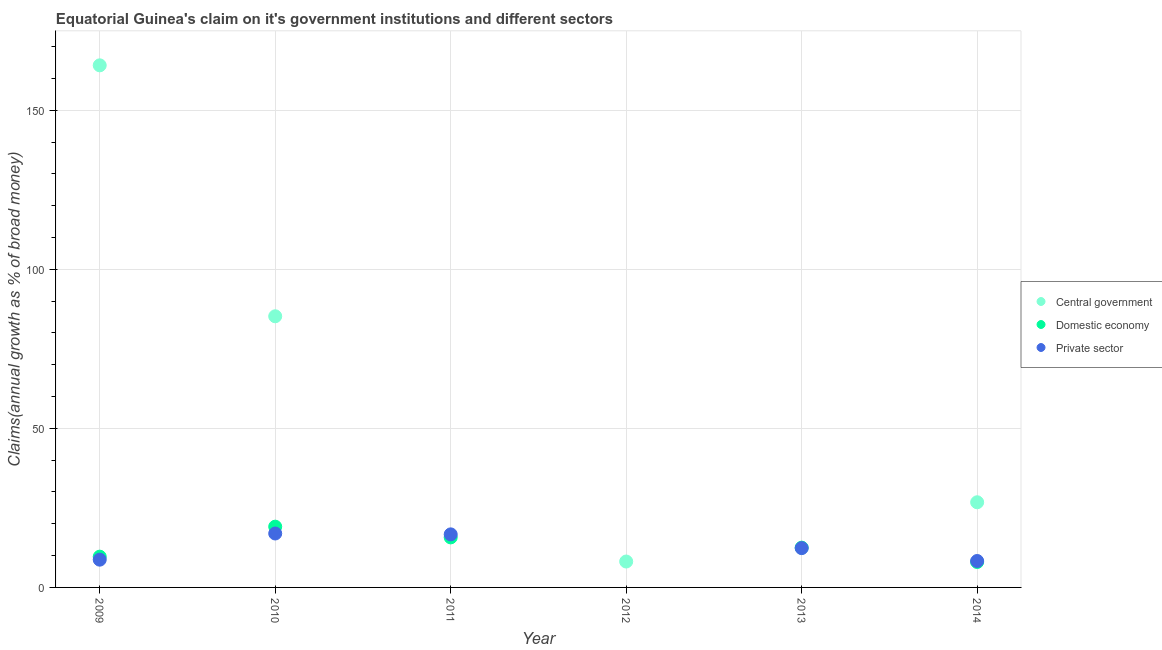How many different coloured dotlines are there?
Provide a short and direct response. 3. What is the percentage of claim on the private sector in 2013?
Offer a terse response. 12.36. Across all years, what is the maximum percentage of claim on the domestic economy?
Your answer should be very brief. 19.1. What is the total percentage of claim on the private sector in the graph?
Provide a short and direct response. 63.03. What is the difference between the percentage of claim on the central government in 2009 and that in 2014?
Offer a very short reply. 137.36. What is the difference between the percentage of claim on the central government in 2011 and the percentage of claim on the domestic economy in 2014?
Provide a succinct answer. -7.99. What is the average percentage of claim on the domestic economy per year?
Your answer should be compact. 10.83. In the year 2014, what is the difference between the percentage of claim on the central government and percentage of claim on the domestic economy?
Your answer should be compact. 18.78. What is the ratio of the percentage of claim on the private sector in 2010 to that in 2013?
Offer a terse response. 1.37. What is the difference between the highest and the second highest percentage of claim on the domestic economy?
Offer a very short reply. 3.37. What is the difference between the highest and the lowest percentage of claim on the central government?
Provide a succinct answer. 164.13. In how many years, is the percentage of claim on the domestic economy greater than the average percentage of claim on the domestic economy taken over all years?
Your response must be concise. 3. Is it the case that in every year, the sum of the percentage of claim on the central government and percentage of claim on the domestic economy is greater than the percentage of claim on the private sector?
Your answer should be compact. No. Is the percentage of claim on the central government strictly greater than the percentage of claim on the private sector over the years?
Provide a succinct answer. No. Is the percentage of claim on the domestic economy strictly less than the percentage of claim on the private sector over the years?
Provide a succinct answer. No. How many years are there in the graph?
Keep it short and to the point. 6. Are the values on the major ticks of Y-axis written in scientific E-notation?
Your answer should be very brief. No. Does the graph contain any zero values?
Give a very brief answer. Yes. Does the graph contain grids?
Offer a very short reply. Yes. Where does the legend appear in the graph?
Give a very brief answer. Center right. What is the title of the graph?
Offer a terse response. Equatorial Guinea's claim on it's government institutions and different sectors. What is the label or title of the X-axis?
Offer a very short reply. Year. What is the label or title of the Y-axis?
Give a very brief answer. Claims(annual growth as % of broad money). What is the Claims(annual growth as % of broad money) of Central government in 2009?
Give a very brief answer. 164.13. What is the Claims(annual growth as % of broad money) of Domestic economy in 2009?
Provide a succinct answer. 9.67. What is the Claims(annual growth as % of broad money) of Private sector in 2009?
Offer a terse response. 8.73. What is the Claims(annual growth as % of broad money) of Central government in 2010?
Your answer should be very brief. 85.24. What is the Claims(annual growth as % of broad money) in Domestic economy in 2010?
Give a very brief answer. 19.1. What is the Claims(annual growth as % of broad money) of Private sector in 2010?
Keep it short and to the point. 16.95. What is the Claims(annual growth as % of broad money) in Central government in 2011?
Your answer should be very brief. 0. What is the Claims(annual growth as % of broad money) in Domestic economy in 2011?
Your answer should be very brief. 15.73. What is the Claims(annual growth as % of broad money) in Private sector in 2011?
Offer a terse response. 16.68. What is the Claims(annual growth as % of broad money) of Central government in 2012?
Offer a very short reply. 8.14. What is the Claims(annual growth as % of broad money) of Private sector in 2012?
Provide a short and direct response. 0. What is the Claims(annual growth as % of broad money) in Domestic economy in 2013?
Ensure brevity in your answer.  12.51. What is the Claims(annual growth as % of broad money) in Private sector in 2013?
Ensure brevity in your answer.  12.36. What is the Claims(annual growth as % of broad money) of Central government in 2014?
Keep it short and to the point. 26.77. What is the Claims(annual growth as % of broad money) of Domestic economy in 2014?
Your answer should be very brief. 7.99. What is the Claims(annual growth as % of broad money) in Private sector in 2014?
Ensure brevity in your answer.  8.31. Across all years, what is the maximum Claims(annual growth as % of broad money) of Central government?
Offer a terse response. 164.13. Across all years, what is the maximum Claims(annual growth as % of broad money) of Domestic economy?
Provide a succinct answer. 19.1. Across all years, what is the maximum Claims(annual growth as % of broad money) in Private sector?
Provide a succinct answer. 16.95. Across all years, what is the minimum Claims(annual growth as % of broad money) in Domestic economy?
Offer a terse response. 0. What is the total Claims(annual growth as % of broad money) of Central government in the graph?
Your answer should be compact. 284.28. What is the total Claims(annual growth as % of broad money) in Domestic economy in the graph?
Your answer should be compact. 65. What is the total Claims(annual growth as % of broad money) in Private sector in the graph?
Offer a terse response. 63.03. What is the difference between the Claims(annual growth as % of broad money) in Central government in 2009 and that in 2010?
Provide a short and direct response. 78.89. What is the difference between the Claims(annual growth as % of broad money) in Domestic economy in 2009 and that in 2010?
Give a very brief answer. -9.43. What is the difference between the Claims(annual growth as % of broad money) of Private sector in 2009 and that in 2010?
Offer a terse response. -8.23. What is the difference between the Claims(annual growth as % of broad money) of Domestic economy in 2009 and that in 2011?
Ensure brevity in your answer.  -6.05. What is the difference between the Claims(annual growth as % of broad money) in Private sector in 2009 and that in 2011?
Offer a very short reply. -7.96. What is the difference between the Claims(annual growth as % of broad money) of Central government in 2009 and that in 2012?
Your response must be concise. 155.98. What is the difference between the Claims(annual growth as % of broad money) in Domestic economy in 2009 and that in 2013?
Make the answer very short. -2.83. What is the difference between the Claims(annual growth as % of broad money) in Private sector in 2009 and that in 2013?
Your answer should be very brief. -3.63. What is the difference between the Claims(annual growth as % of broad money) of Central government in 2009 and that in 2014?
Your answer should be very brief. 137.36. What is the difference between the Claims(annual growth as % of broad money) of Domestic economy in 2009 and that in 2014?
Ensure brevity in your answer.  1.68. What is the difference between the Claims(annual growth as % of broad money) in Private sector in 2009 and that in 2014?
Your answer should be very brief. 0.42. What is the difference between the Claims(annual growth as % of broad money) in Domestic economy in 2010 and that in 2011?
Give a very brief answer. 3.37. What is the difference between the Claims(annual growth as % of broad money) of Private sector in 2010 and that in 2011?
Your answer should be compact. 0.27. What is the difference between the Claims(annual growth as % of broad money) of Central government in 2010 and that in 2012?
Your answer should be compact. 77.1. What is the difference between the Claims(annual growth as % of broad money) in Domestic economy in 2010 and that in 2013?
Your answer should be compact. 6.6. What is the difference between the Claims(annual growth as % of broad money) in Private sector in 2010 and that in 2013?
Keep it short and to the point. 4.59. What is the difference between the Claims(annual growth as % of broad money) in Central government in 2010 and that in 2014?
Give a very brief answer. 58.47. What is the difference between the Claims(annual growth as % of broad money) of Domestic economy in 2010 and that in 2014?
Offer a very short reply. 11.11. What is the difference between the Claims(annual growth as % of broad money) of Private sector in 2010 and that in 2014?
Ensure brevity in your answer.  8.64. What is the difference between the Claims(annual growth as % of broad money) of Domestic economy in 2011 and that in 2013?
Offer a terse response. 3.22. What is the difference between the Claims(annual growth as % of broad money) in Private sector in 2011 and that in 2013?
Ensure brevity in your answer.  4.32. What is the difference between the Claims(annual growth as % of broad money) of Domestic economy in 2011 and that in 2014?
Provide a succinct answer. 7.73. What is the difference between the Claims(annual growth as % of broad money) in Private sector in 2011 and that in 2014?
Your answer should be very brief. 8.37. What is the difference between the Claims(annual growth as % of broad money) of Central government in 2012 and that in 2014?
Give a very brief answer. -18.63. What is the difference between the Claims(annual growth as % of broad money) in Domestic economy in 2013 and that in 2014?
Provide a succinct answer. 4.51. What is the difference between the Claims(annual growth as % of broad money) of Private sector in 2013 and that in 2014?
Offer a terse response. 4.05. What is the difference between the Claims(annual growth as % of broad money) in Central government in 2009 and the Claims(annual growth as % of broad money) in Domestic economy in 2010?
Your answer should be very brief. 145.03. What is the difference between the Claims(annual growth as % of broad money) of Central government in 2009 and the Claims(annual growth as % of broad money) of Private sector in 2010?
Make the answer very short. 147.17. What is the difference between the Claims(annual growth as % of broad money) in Domestic economy in 2009 and the Claims(annual growth as % of broad money) in Private sector in 2010?
Provide a short and direct response. -7.28. What is the difference between the Claims(annual growth as % of broad money) of Central government in 2009 and the Claims(annual growth as % of broad money) of Domestic economy in 2011?
Your response must be concise. 148.4. What is the difference between the Claims(annual growth as % of broad money) in Central government in 2009 and the Claims(annual growth as % of broad money) in Private sector in 2011?
Your answer should be very brief. 147.45. What is the difference between the Claims(annual growth as % of broad money) in Domestic economy in 2009 and the Claims(annual growth as % of broad money) in Private sector in 2011?
Your response must be concise. -7.01. What is the difference between the Claims(annual growth as % of broad money) of Central government in 2009 and the Claims(annual growth as % of broad money) of Domestic economy in 2013?
Provide a succinct answer. 151.62. What is the difference between the Claims(annual growth as % of broad money) of Central government in 2009 and the Claims(annual growth as % of broad money) of Private sector in 2013?
Keep it short and to the point. 151.77. What is the difference between the Claims(annual growth as % of broad money) of Domestic economy in 2009 and the Claims(annual growth as % of broad money) of Private sector in 2013?
Provide a short and direct response. -2.69. What is the difference between the Claims(annual growth as % of broad money) of Central government in 2009 and the Claims(annual growth as % of broad money) of Domestic economy in 2014?
Give a very brief answer. 156.13. What is the difference between the Claims(annual growth as % of broad money) of Central government in 2009 and the Claims(annual growth as % of broad money) of Private sector in 2014?
Your response must be concise. 155.82. What is the difference between the Claims(annual growth as % of broad money) in Domestic economy in 2009 and the Claims(annual growth as % of broad money) in Private sector in 2014?
Your answer should be compact. 1.36. What is the difference between the Claims(annual growth as % of broad money) of Central government in 2010 and the Claims(annual growth as % of broad money) of Domestic economy in 2011?
Your answer should be very brief. 69.51. What is the difference between the Claims(annual growth as % of broad money) of Central government in 2010 and the Claims(annual growth as % of broad money) of Private sector in 2011?
Your answer should be compact. 68.56. What is the difference between the Claims(annual growth as % of broad money) of Domestic economy in 2010 and the Claims(annual growth as % of broad money) of Private sector in 2011?
Your response must be concise. 2.42. What is the difference between the Claims(annual growth as % of broad money) of Central government in 2010 and the Claims(annual growth as % of broad money) of Domestic economy in 2013?
Offer a very short reply. 72.73. What is the difference between the Claims(annual growth as % of broad money) in Central government in 2010 and the Claims(annual growth as % of broad money) in Private sector in 2013?
Make the answer very short. 72.88. What is the difference between the Claims(annual growth as % of broad money) of Domestic economy in 2010 and the Claims(annual growth as % of broad money) of Private sector in 2013?
Provide a succinct answer. 6.74. What is the difference between the Claims(annual growth as % of broad money) of Central government in 2010 and the Claims(annual growth as % of broad money) of Domestic economy in 2014?
Keep it short and to the point. 77.25. What is the difference between the Claims(annual growth as % of broad money) in Central government in 2010 and the Claims(annual growth as % of broad money) in Private sector in 2014?
Your answer should be compact. 76.93. What is the difference between the Claims(annual growth as % of broad money) of Domestic economy in 2010 and the Claims(annual growth as % of broad money) of Private sector in 2014?
Your response must be concise. 10.79. What is the difference between the Claims(annual growth as % of broad money) of Domestic economy in 2011 and the Claims(annual growth as % of broad money) of Private sector in 2013?
Ensure brevity in your answer.  3.37. What is the difference between the Claims(annual growth as % of broad money) in Domestic economy in 2011 and the Claims(annual growth as % of broad money) in Private sector in 2014?
Your answer should be very brief. 7.42. What is the difference between the Claims(annual growth as % of broad money) in Central government in 2012 and the Claims(annual growth as % of broad money) in Domestic economy in 2013?
Your answer should be very brief. -4.36. What is the difference between the Claims(annual growth as % of broad money) in Central government in 2012 and the Claims(annual growth as % of broad money) in Private sector in 2013?
Keep it short and to the point. -4.22. What is the difference between the Claims(annual growth as % of broad money) in Central government in 2012 and the Claims(annual growth as % of broad money) in Domestic economy in 2014?
Your answer should be very brief. 0.15. What is the difference between the Claims(annual growth as % of broad money) in Central government in 2012 and the Claims(annual growth as % of broad money) in Private sector in 2014?
Ensure brevity in your answer.  -0.17. What is the difference between the Claims(annual growth as % of broad money) of Domestic economy in 2013 and the Claims(annual growth as % of broad money) of Private sector in 2014?
Your response must be concise. 4.2. What is the average Claims(annual growth as % of broad money) in Central government per year?
Provide a succinct answer. 47.38. What is the average Claims(annual growth as % of broad money) of Domestic economy per year?
Offer a terse response. 10.83. What is the average Claims(annual growth as % of broad money) in Private sector per year?
Ensure brevity in your answer.  10.51. In the year 2009, what is the difference between the Claims(annual growth as % of broad money) in Central government and Claims(annual growth as % of broad money) in Domestic economy?
Your response must be concise. 154.45. In the year 2009, what is the difference between the Claims(annual growth as % of broad money) in Central government and Claims(annual growth as % of broad money) in Private sector?
Offer a terse response. 155.4. In the year 2009, what is the difference between the Claims(annual growth as % of broad money) of Domestic economy and Claims(annual growth as % of broad money) of Private sector?
Give a very brief answer. 0.95. In the year 2010, what is the difference between the Claims(annual growth as % of broad money) of Central government and Claims(annual growth as % of broad money) of Domestic economy?
Offer a terse response. 66.14. In the year 2010, what is the difference between the Claims(annual growth as % of broad money) in Central government and Claims(annual growth as % of broad money) in Private sector?
Provide a succinct answer. 68.29. In the year 2010, what is the difference between the Claims(annual growth as % of broad money) in Domestic economy and Claims(annual growth as % of broad money) in Private sector?
Offer a terse response. 2.15. In the year 2011, what is the difference between the Claims(annual growth as % of broad money) of Domestic economy and Claims(annual growth as % of broad money) of Private sector?
Your answer should be very brief. -0.95. In the year 2013, what is the difference between the Claims(annual growth as % of broad money) in Domestic economy and Claims(annual growth as % of broad money) in Private sector?
Keep it short and to the point. 0.14. In the year 2014, what is the difference between the Claims(annual growth as % of broad money) in Central government and Claims(annual growth as % of broad money) in Domestic economy?
Ensure brevity in your answer.  18.78. In the year 2014, what is the difference between the Claims(annual growth as % of broad money) in Central government and Claims(annual growth as % of broad money) in Private sector?
Give a very brief answer. 18.46. In the year 2014, what is the difference between the Claims(annual growth as % of broad money) of Domestic economy and Claims(annual growth as % of broad money) of Private sector?
Your response must be concise. -0.32. What is the ratio of the Claims(annual growth as % of broad money) in Central government in 2009 to that in 2010?
Give a very brief answer. 1.93. What is the ratio of the Claims(annual growth as % of broad money) in Domestic economy in 2009 to that in 2010?
Your answer should be compact. 0.51. What is the ratio of the Claims(annual growth as % of broad money) in Private sector in 2009 to that in 2010?
Provide a short and direct response. 0.51. What is the ratio of the Claims(annual growth as % of broad money) in Domestic economy in 2009 to that in 2011?
Make the answer very short. 0.61. What is the ratio of the Claims(annual growth as % of broad money) in Private sector in 2009 to that in 2011?
Keep it short and to the point. 0.52. What is the ratio of the Claims(annual growth as % of broad money) of Central government in 2009 to that in 2012?
Your response must be concise. 20.15. What is the ratio of the Claims(annual growth as % of broad money) of Domestic economy in 2009 to that in 2013?
Your answer should be compact. 0.77. What is the ratio of the Claims(annual growth as % of broad money) in Private sector in 2009 to that in 2013?
Give a very brief answer. 0.71. What is the ratio of the Claims(annual growth as % of broad money) of Central government in 2009 to that in 2014?
Offer a very short reply. 6.13. What is the ratio of the Claims(annual growth as % of broad money) of Domestic economy in 2009 to that in 2014?
Offer a terse response. 1.21. What is the ratio of the Claims(annual growth as % of broad money) in Domestic economy in 2010 to that in 2011?
Ensure brevity in your answer.  1.21. What is the ratio of the Claims(annual growth as % of broad money) in Private sector in 2010 to that in 2011?
Make the answer very short. 1.02. What is the ratio of the Claims(annual growth as % of broad money) in Central government in 2010 to that in 2012?
Your response must be concise. 10.47. What is the ratio of the Claims(annual growth as % of broad money) of Domestic economy in 2010 to that in 2013?
Offer a terse response. 1.53. What is the ratio of the Claims(annual growth as % of broad money) of Private sector in 2010 to that in 2013?
Offer a terse response. 1.37. What is the ratio of the Claims(annual growth as % of broad money) in Central government in 2010 to that in 2014?
Offer a terse response. 3.18. What is the ratio of the Claims(annual growth as % of broad money) in Domestic economy in 2010 to that in 2014?
Offer a very short reply. 2.39. What is the ratio of the Claims(annual growth as % of broad money) of Private sector in 2010 to that in 2014?
Give a very brief answer. 2.04. What is the ratio of the Claims(annual growth as % of broad money) of Domestic economy in 2011 to that in 2013?
Your answer should be compact. 1.26. What is the ratio of the Claims(annual growth as % of broad money) of Private sector in 2011 to that in 2013?
Offer a terse response. 1.35. What is the ratio of the Claims(annual growth as % of broad money) of Domestic economy in 2011 to that in 2014?
Offer a very short reply. 1.97. What is the ratio of the Claims(annual growth as % of broad money) in Private sector in 2011 to that in 2014?
Your answer should be compact. 2.01. What is the ratio of the Claims(annual growth as % of broad money) in Central government in 2012 to that in 2014?
Your answer should be very brief. 0.3. What is the ratio of the Claims(annual growth as % of broad money) in Domestic economy in 2013 to that in 2014?
Offer a very short reply. 1.56. What is the ratio of the Claims(annual growth as % of broad money) in Private sector in 2013 to that in 2014?
Your response must be concise. 1.49. What is the difference between the highest and the second highest Claims(annual growth as % of broad money) of Central government?
Offer a terse response. 78.89. What is the difference between the highest and the second highest Claims(annual growth as % of broad money) of Domestic economy?
Provide a short and direct response. 3.37. What is the difference between the highest and the second highest Claims(annual growth as % of broad money) in Private sector?
Provide a short and direct response. 0.27. What is the difference between the highest and the lowest Claims(annual growth as % of broad money) in Central government?
Provide a succinct answer. 164.13. What is the difference between the highest and the lowest Claims(annual growth as % of broad money) in Domestic economy?
Provide a succinct answer. 19.1. What is the difference between the highest and the lowest Claims(annual growth as % of broad money) of Private sector?
Make the answer very short. 16.95. 